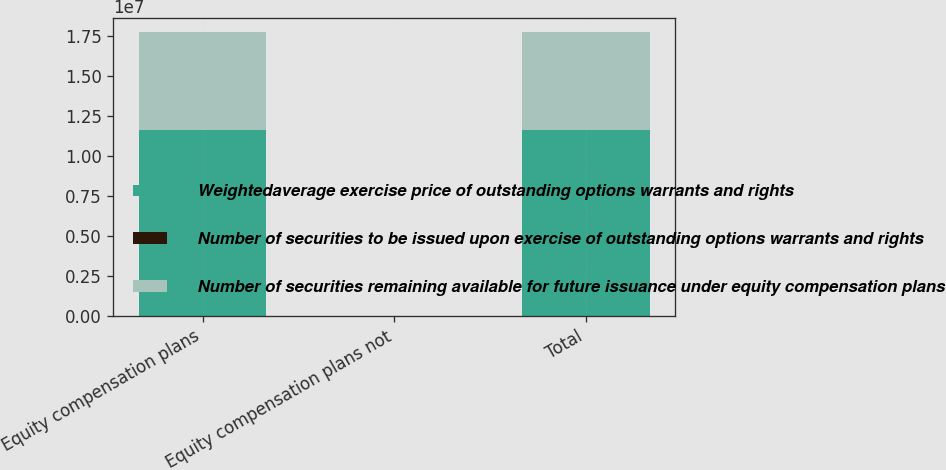<chart> <loc_0><loc_0><loc_500><loc_500><stacked_bar_chart><ecel><fcel>Equity compensation plans<fcel>Equity compensation plans not<fcel>Total<nl><fcel>Weightedaverage exercise price of outstanding options warrants and rights<fcel>1.16204e+07<fcel>0<fcel>1.16204e+07<nl><fcel>Number of securities to be issued upon exercise of outstanding options warrants and rights<fcel>35.42<fcel>0<fcel>35.42<nl><fcel>Number of securities remaining available for future issuance under equity compensation plans<fcel>6.09934e+06<fcel>0<fcel>6.09934e+06<nl></chart> 